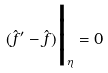Convert formula to latex. <formula><loc_0><loc_0><loc_500><loc_500>( \hat { f } ^ { \prime } - \hat { f } ) \Big | _ { \eta } = 0</formula> 